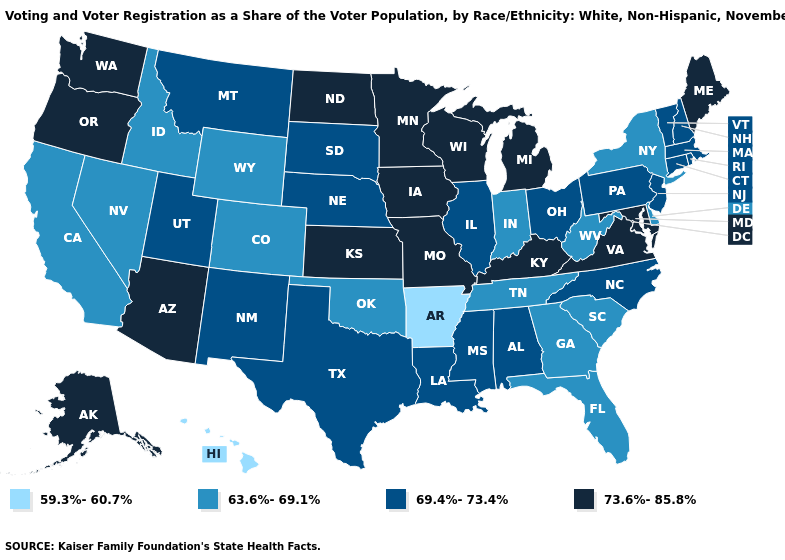Does the map have missing data?
Quick response, please. No. Does the first symbol in the legend represent the smallest category?
Answer briefly. Yes. What is the value of Missouri?
Short answer required. 73.6%-85.8%. Among the states that border Virginia , does Kentucky have the highest value?
Be succinct. Yes. Name the states that have a value in the range 63.6%-69.1%?
Be succinct. California, Colorado, Delaware, Florida, Georgia, Idaho, Indiana, Nevada, New York, Oklahoma, South Carolina, Tennessee, West Virginia, Wyoming. Does the first symbol in the legend represent the smallest category?
Answer briefly. Yes. What is the lowest value in states that border Oklahoma?
Give a very brief answer. 59.3%-60.7%. What is the lowest value in the Northeast?
Be succinct. 63.6%-69.1%. Does Maryland have the highest value in the USA?
Write a very short answer. Yes. Which states have the lowest value in the USA?
Concise answer only. Arkansas, Hawaii. Among the states that border Minnesota , which have the highest value?
Quick response, please. Iowa, North Dakota, Wisconsin. Name the states that have a value in the range 63.6%-69.1%?
Answer briefly. California, Colorado, Delaware, Florida, Georgia, Idaho, Indiana, Nevada, New York, Oklahoma, South Carolina, Tennessee, West Virginia, Wyoming. What is the lowest value in the Northeast?
Quick response, please. 63.6%-69.1%. Name the states that have a value in the range 69.4%-73.4%?
Write a very short answer. Alabama, Connecticut, Illinois, Louisiana, Massachusetts, Mississippi, Montana, Nebraska, New Hampshire, New Jersey, New Mexico, North Carolina, Ohio, Pennsylvania, Rhode Island, South Dakota, Texas, Utah, Vermont. What is the lowest value in states that border Pennsylvania?
Short answer required. 63.6%-69.1%. 